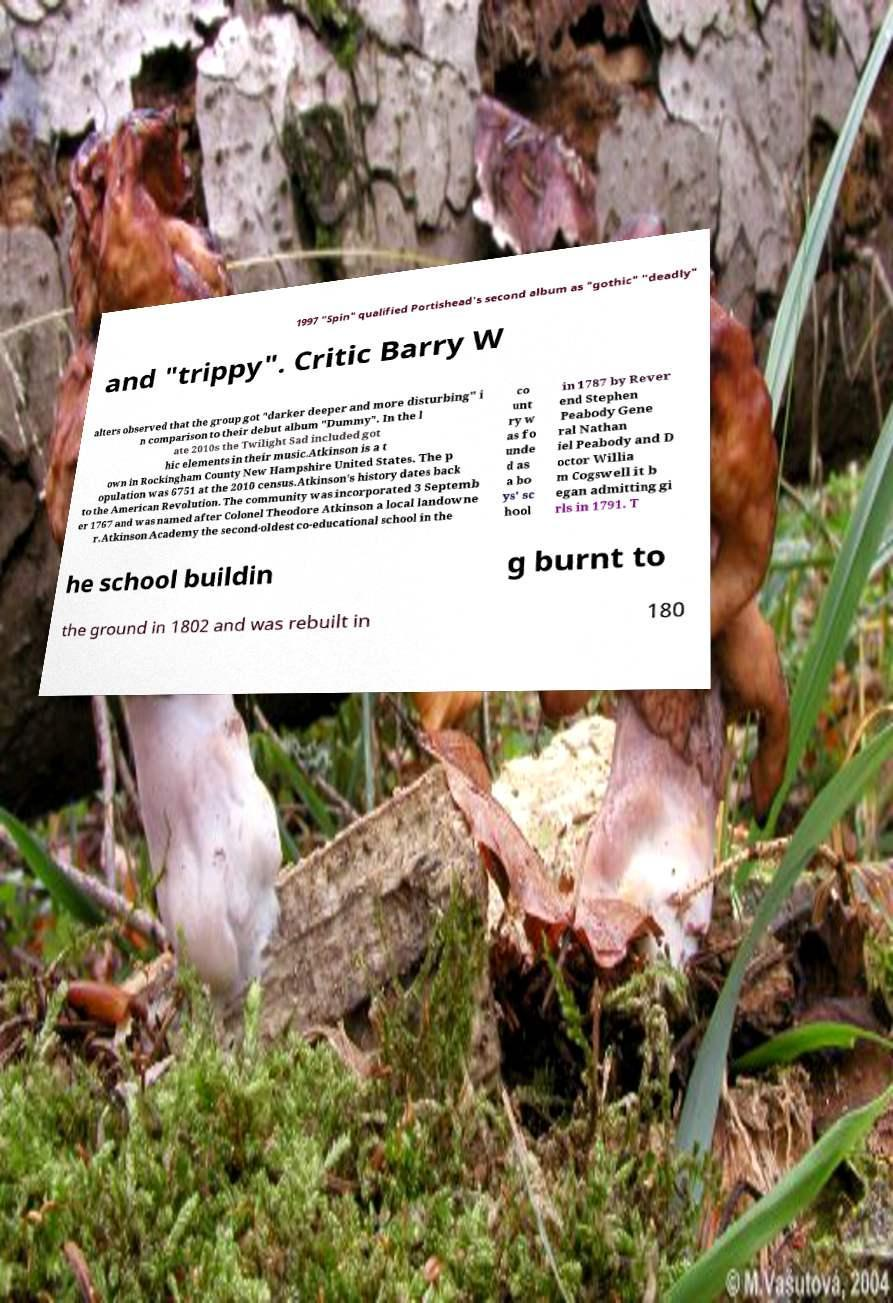What messages or text are displayed in this image? I need them in a readable, typed format. 1997 "Spin" qualified Portishead's second album as "gothic" "deadly" and "trippy". Critic Barry W alters observed that the group got "darker deeper and more disturbing" i n comparison to their debut album "Dummy". In the l ate 2010s the Twilight Sad included got hic elements in their music.Atkinson is a t own in Rockingham County New Hampshire United States. The p opulation was 6751 at the 2010 census.Atkinson's history dates back to the American Revolution. The community was incorporated 3 Septemb er 1767 and was named after Colonel Theodore Atkinson a local landowne r.Atkinson Academy the second-oldest co-educational school in the co unt ry w as fo unde d as a bo ys' sc hool in 1787 by Rever end Stephen Peabody Gene ral Nathan iel Peabody and D octor Willia m Cogswell it b egan admitting gi rls in 1791. T he school buildin g burnt to the ground in 1802 and was rebuilt in 180 